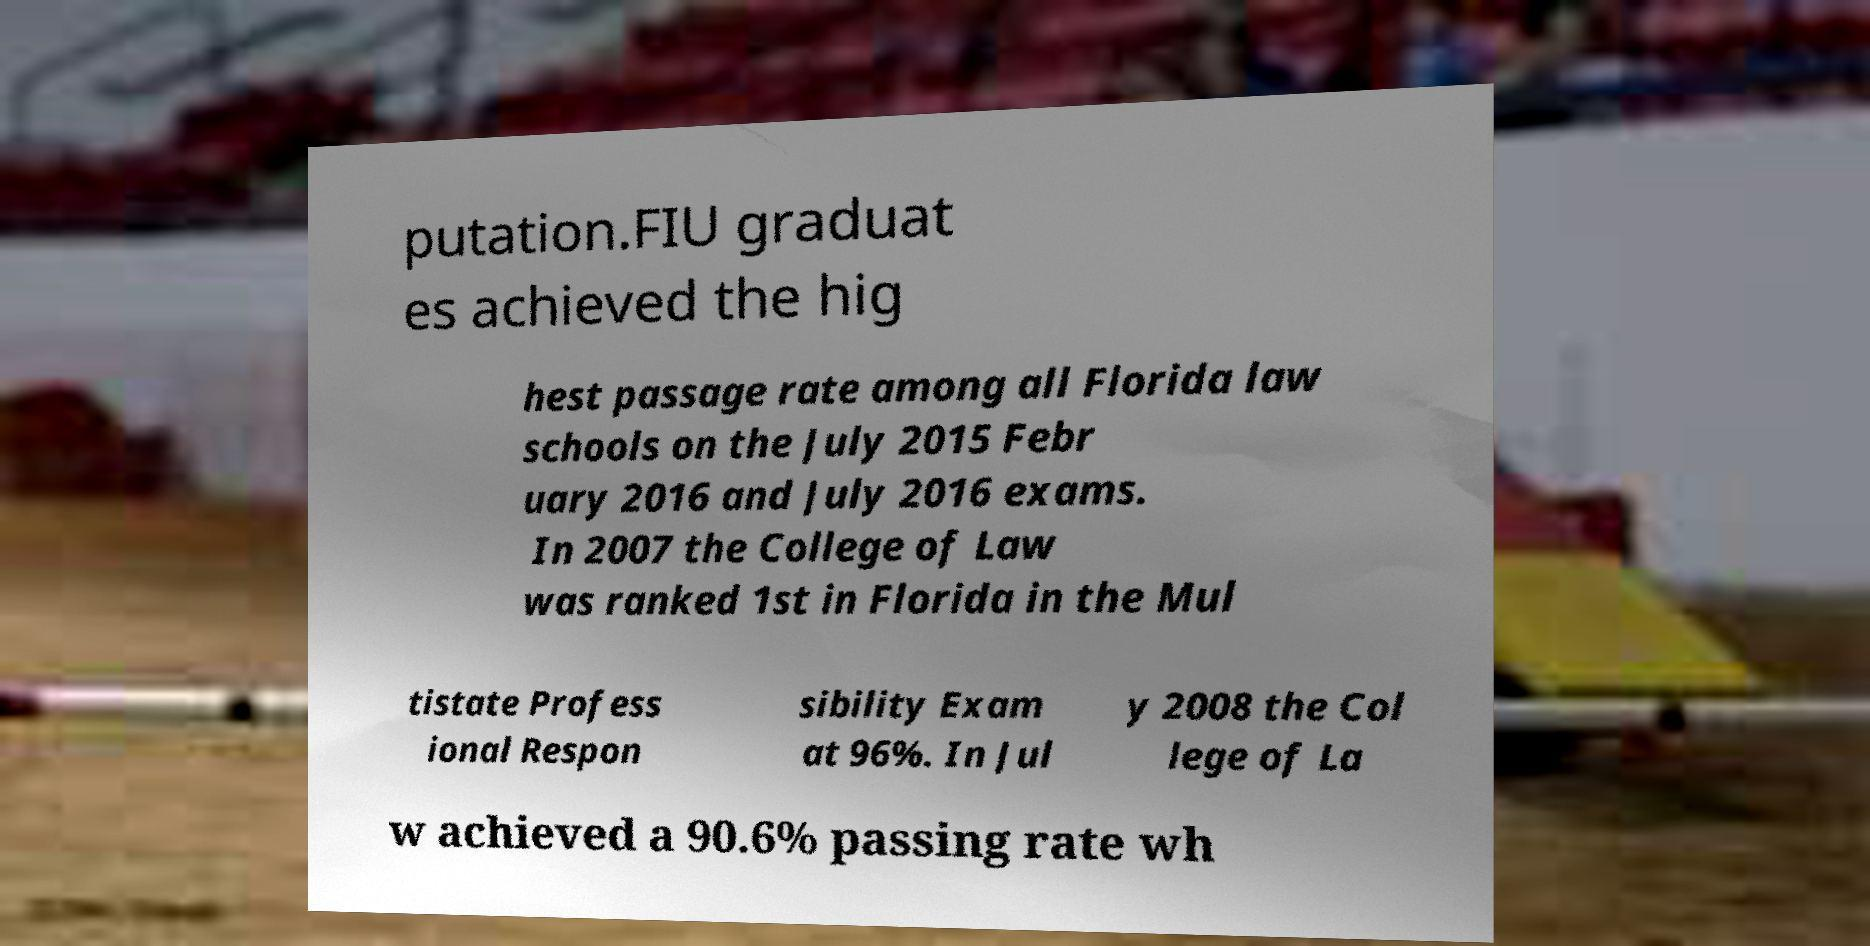For documentation purposes, I need the text within this image transcribed. Could you provide that? putation.FIU graduat es achieved the hig hest passage rate among all Florida law schools on the July 2015 Febr uary 2016 and July 2016 exams. In 2007 the College of Law was ranked 1st in Florida in the Mul tistate Profess ional Respon sibility Exam at 96%. In Jul y 2008 the Col lege of La w achieved a 90.6% passing rate wh 